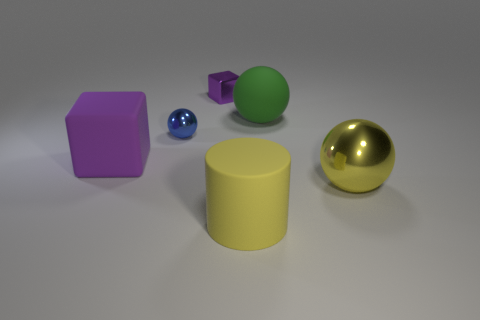There is another ball that is made of the same material as the yellow sphere; what is its size?
Give a very brief answer. Small. Are there any other rubber objects that have the same shape as the blue object?
Provide a short and direct response. Yes. How many objects are purple objects that are on the left side of the large yellow matte cylinder or small red rubber things?
Offer a terse response. 2. What is the size of the metallic object that is the same color as the big matte block?
Make the answer very short. Small. Does the matte object in front of the big shiny ball have the same color as the sphere that is in front of the tiny blue metal thing?
Ensure brevity in your answer.  Yes. What size is the shiny block?
Provide a succinct answer. Small. What number of large things are balls or cylinders?
Make the answer very short. 3. There is a block that is the same size as the yellow cylinder; what is its color?
Give a very brief answer. Purple. How many other things are the same shape as the large purple object?
Make the answer very short. 1. Are there any tiny cubes that have the same material as the yellow ball?
Provide a short and direct response. Yes. 